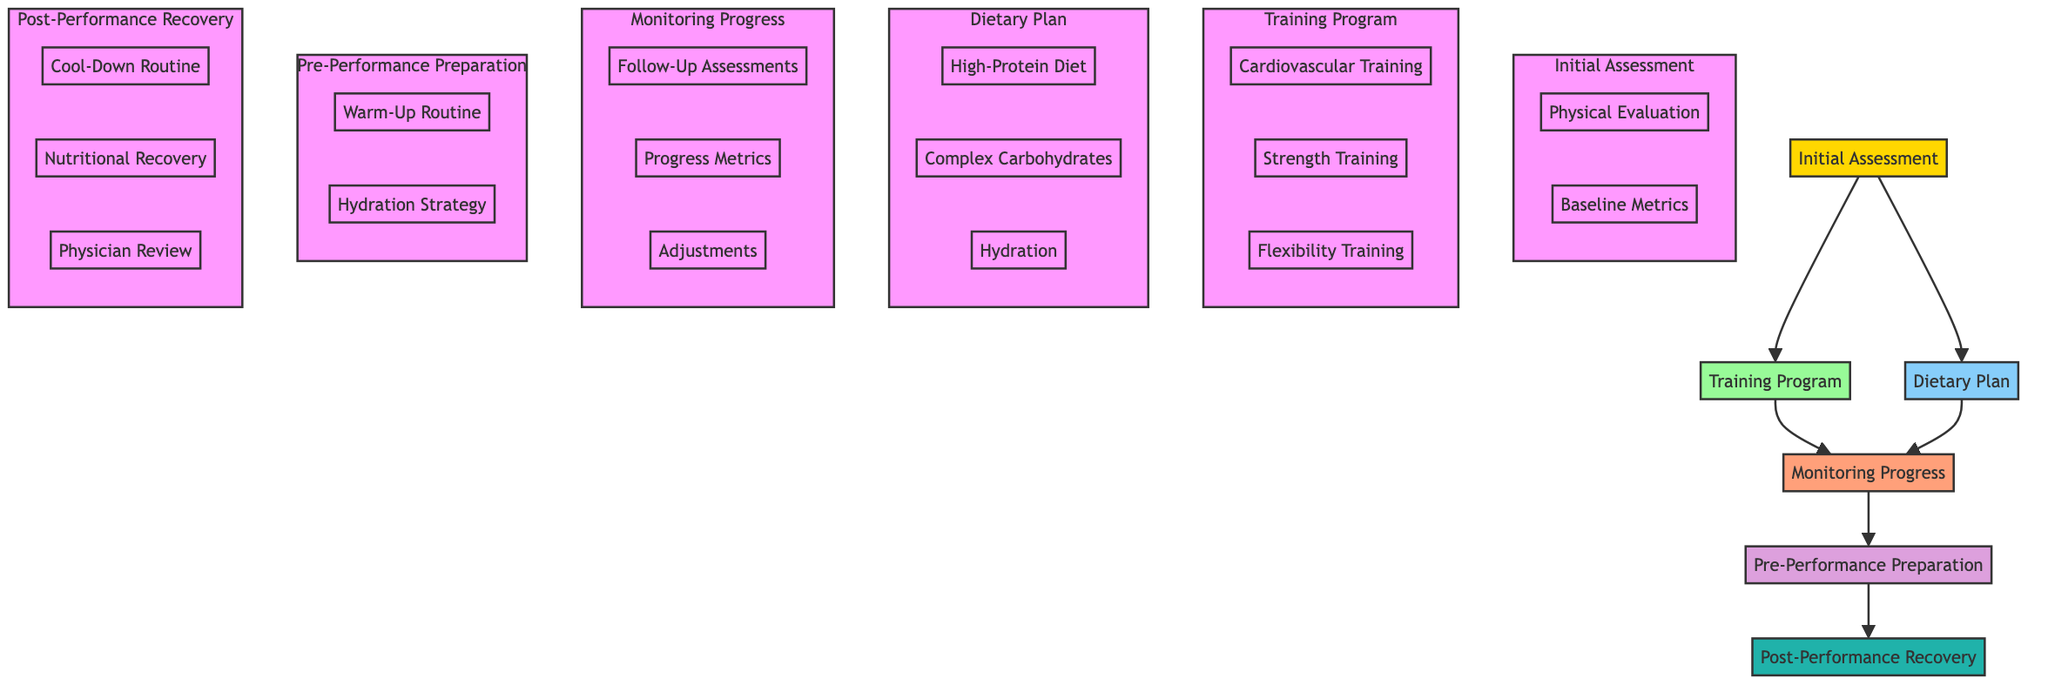What physician conducted the initial assessment? The initial assessment node lists a specific doctor associated with it, which is Dr. Maria Schulz.
Answer: Dr. Maria Schulz How many times per week is cardiovascular training scheduled? The training program node details the frequency of cardiovascular training, which indicates that it occurs 3 times per week.
Answer: 3 times per week What exercise method is included in the strength training program? Within the training program node, it shows two types of exercises listed, one being Resistance Bands.
Answer: Resistance Bands What is included in the dietary plan? The dietary plan node has three distinct components as part of its list: High-Protein Diet, Complex Carbohydrates, and Hydration.
Answer: High-Protein Diet What is the duration of the warm-up routine? The pre-performance preparation node clearly states the duration of the warm-up routine, which is 15 minutes.
Answer: 15 minutes How are follow-up assessments scheduled? The monitoring progress node specifies that both physician and dietitian follow-ups occur every 4 weeks, indicating a standardized routine for monitoring.
Answer: Every 4 weeks What types of activities are included in the cool-down routine? The post-performance recovery node describes the cool-down routine and highlights two specific activities: Light Jogging and Static Stretches.
Answer: Light Jogging, Static Stretches What is the timing for nutritional recovery? Looking at the nutritional recovery segment in the post-performance recovery, it indicates that intake should happen within 30 minutes post-performance.
Answer: Within 30 minutes post-performance What is the hydration strategy during the performance? The pre-performance preparation node describes a hydration strategy where sips of water are taken every 15 minutes during performance.
Answer: Sips of water every 15 minutes 